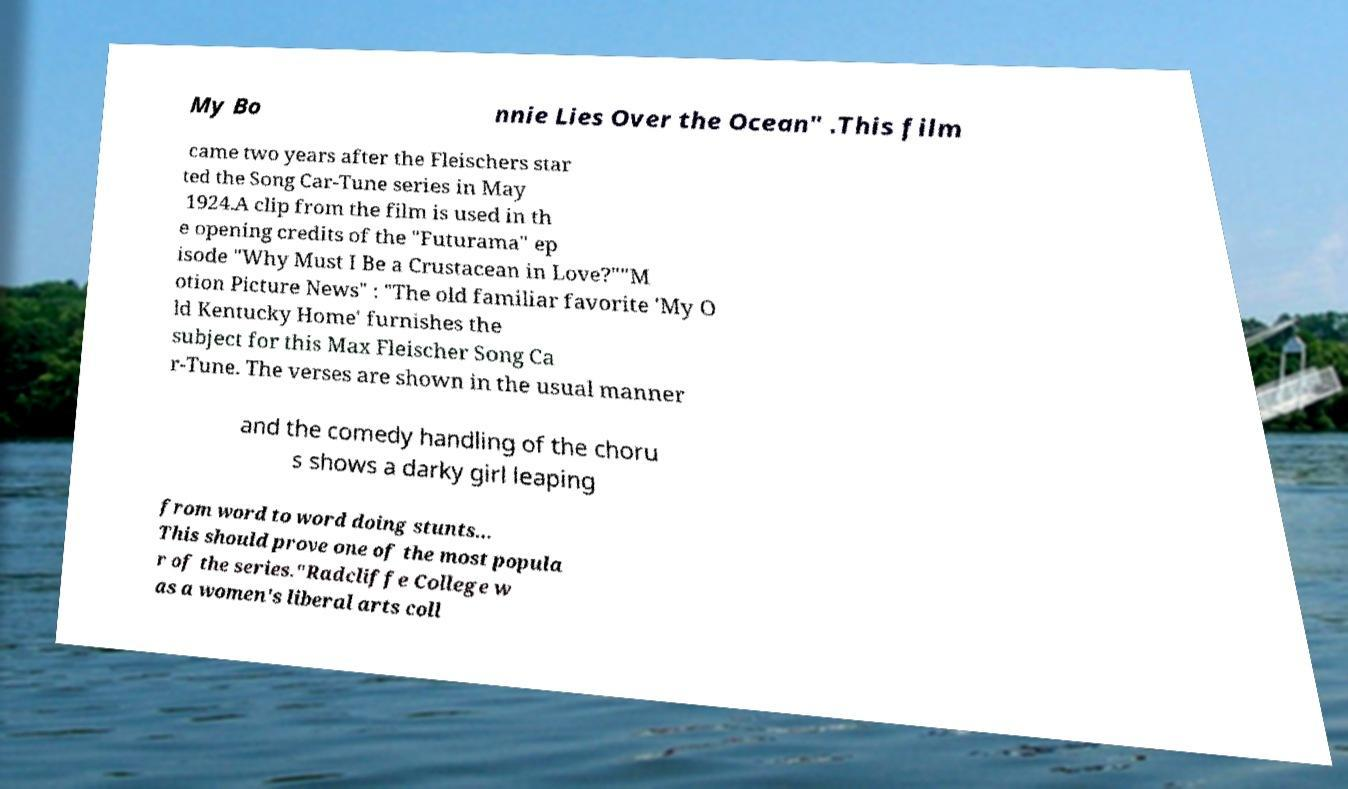Can you accurately transcribe the text from the provided image for me? My Bo nnie Lies Over the Ocean" .This film came two years after the Fleischers star ted the Song Car-Tune series in May 1924.A clip from the film is used in th e opening credits of the "Futurama" ep isode "Why Must I Be a Crustacean in Love?""M otion Picture News" : "The old familiar favorite 'My O ld Kentucky Home' furnishes the subject for this Max Fleischer Song Ca r-Tune. The verses are shown in the usual manner and the comedy handling of the choru s shows a darky girl leaping from word to word doing stunts... This should prove one of the most popula r of the series."Radcliffe College w as a women's liberal arts coll 